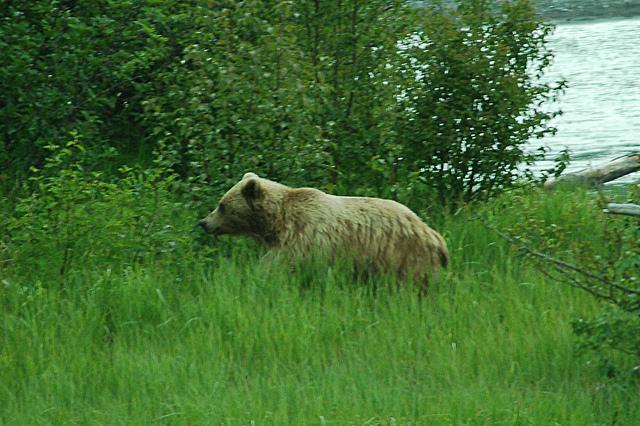How many red umbrellas are there?
Give a very brief answer. 0. 